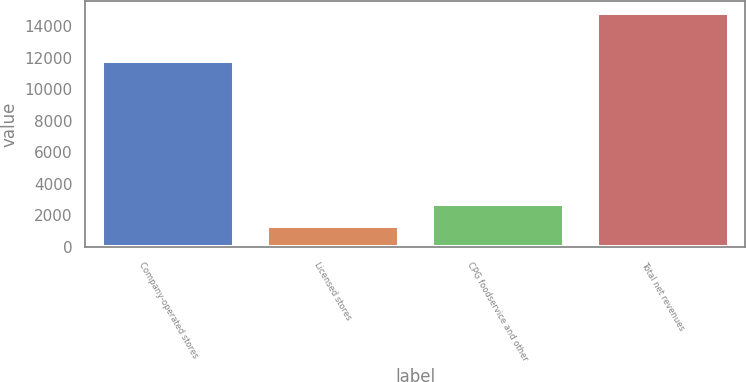Convert chart to OTSL. <chart><loc_0><loc_0><loc_500><loc_500><bar_chart><fcel>Company-operated stores<fcel>Licensed stores<fcel>CPG foodservice and other<fcel>Total net revenues<nl><fcel>11793.2<fcel>1360.5<fcel>2711.13<fcel>14866.8<nl></chart> 